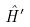Convert formula to latex. <formula><loc_0><loc_0><loc_500><loc_500>\hat { H } ^ { \prime }</formula> 